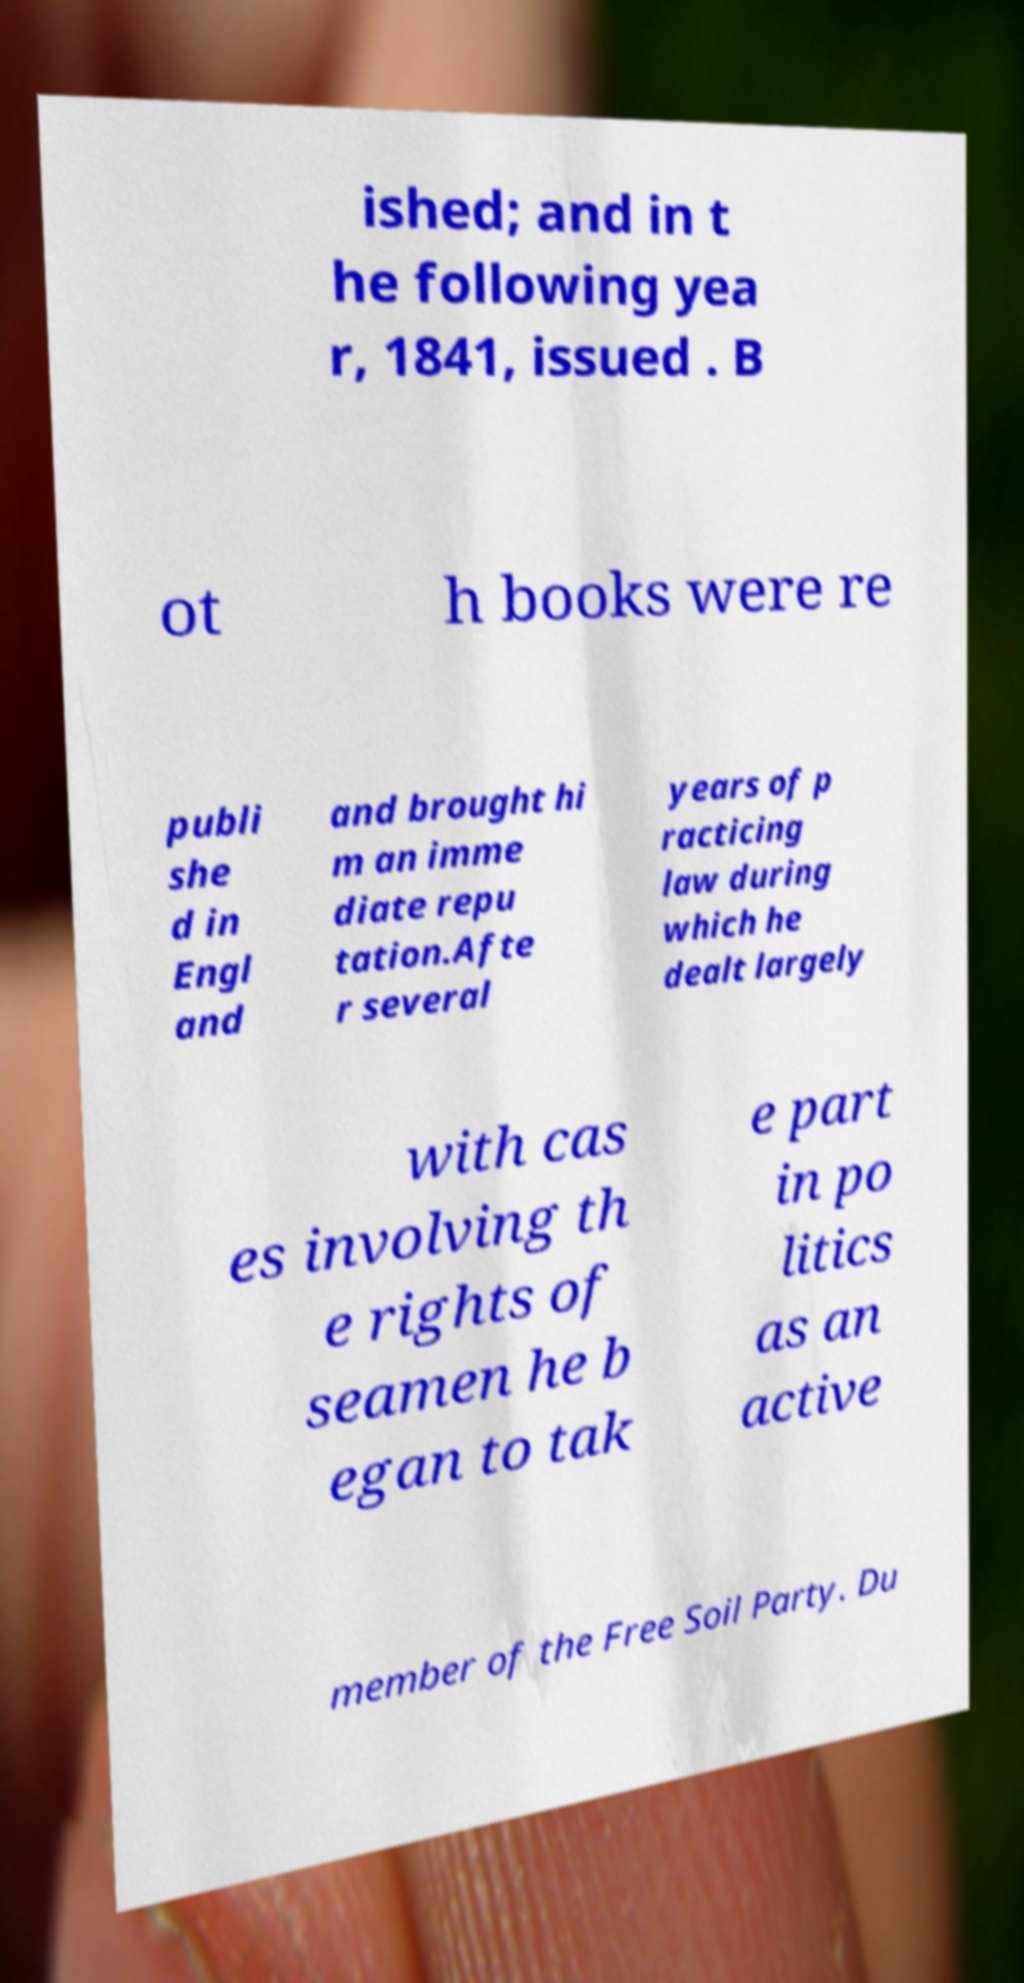Could you extract and type out the text from this image? ished; and in t he following yea r, 1841, issued . B ot h books were re publi she d in Engl and and brought hi m an imme diate repu tation.Afte r several years of p racticing law during which he dealt largely with cas es involving th e rights of seamen he b egan to tak e part in po litics as an active member of the Free Soil Party. Du 